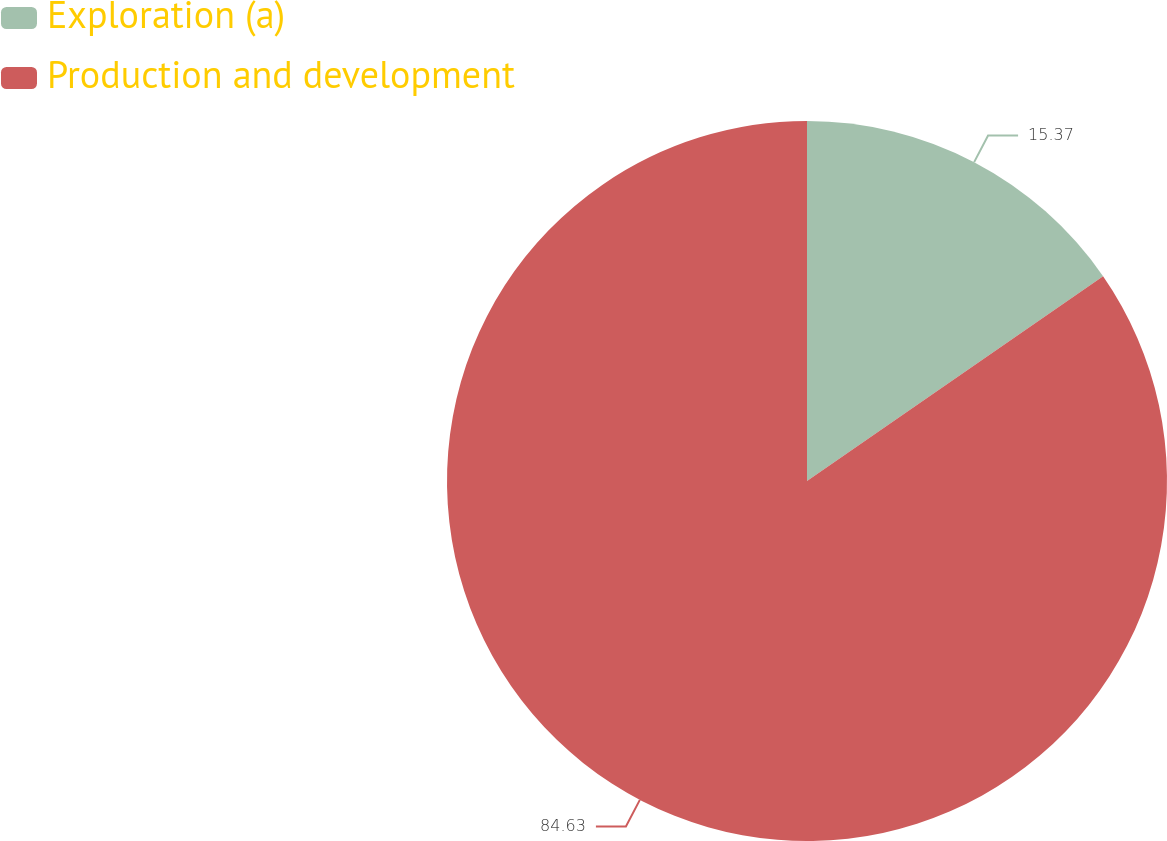Convert chart to OTSL. <chart><loc_0><loc_0><loc_500><loc_500><pie_chart><fcel>Exploration (a)<fcel>Production and development<nl><fcel>15.37%<fcel>84.63%<nl></chart> 